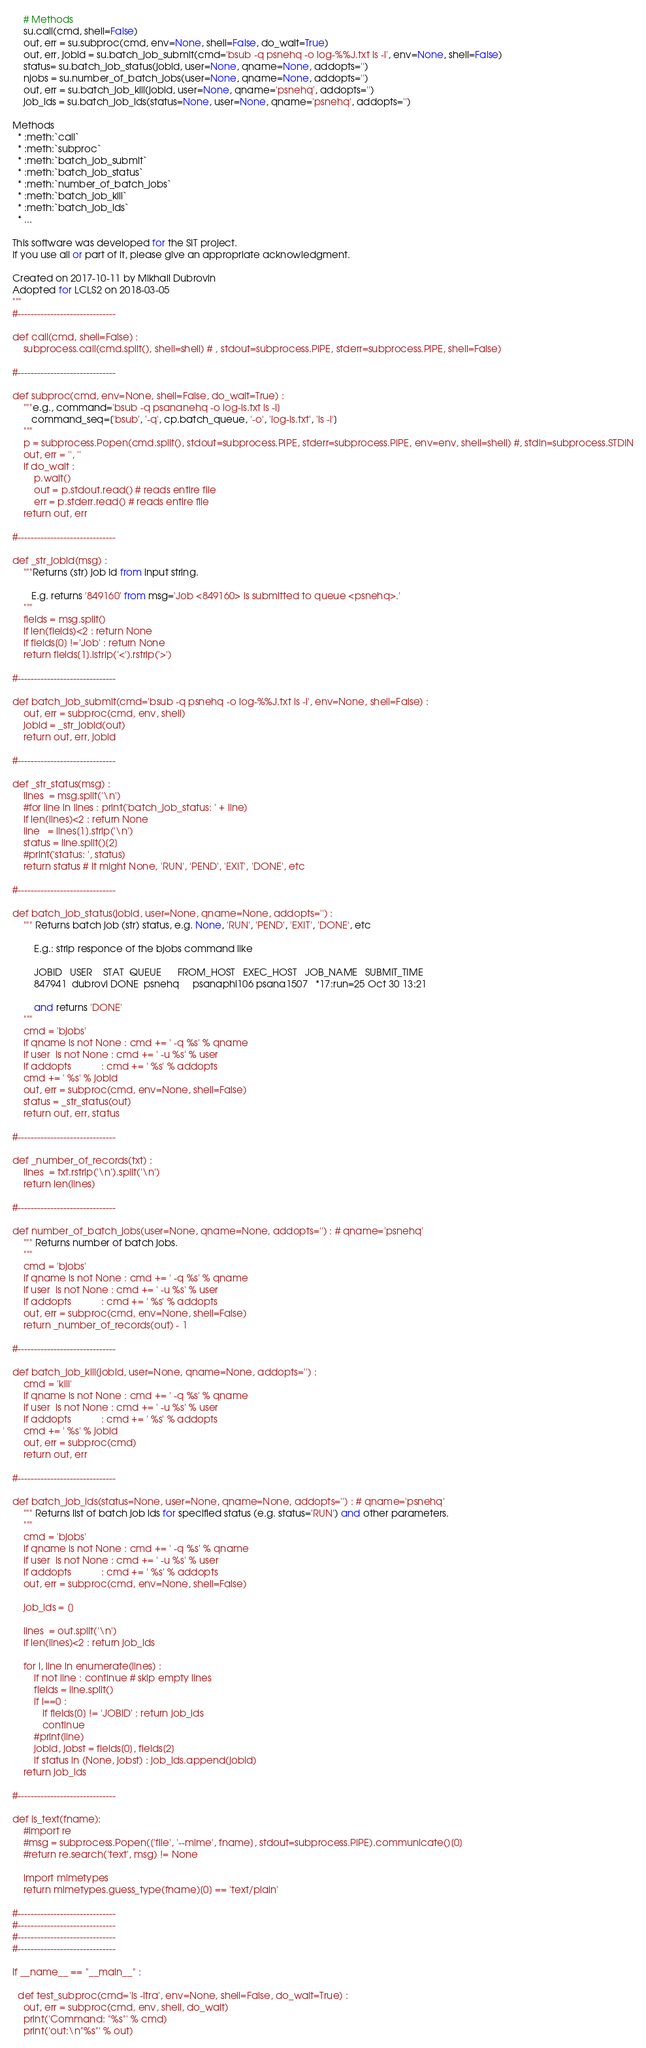Convert code to text. <code><loc_0><loc_0><loc_500><loc_500><_Python_>    # Methods
    su.call(cmd, shell=False)
    out, err = su.subproc(cmd, env=None, shell=False, do_wait=True)
    out, err, jobid = su.batch_job_submit(cmd='bsub -q psnehq -o log-%%J.txt ls -l', env=None, shell=False)
    status= su.batch_job_status(jobid, user=None, qname=None, addopts='')
    njobs = su.number_of_batch_jobs(user=None, qname=None, addopts='')
    out, err = su.batch_job_kill(jobid, user=None, qname='psnehq', addopts='')
    job_ids = su.batch_job_ids(status=None, user=None, qname='psnehq', addopts='')

Methods 
  * :meth:`call`
  * :meth:`subproc`
  * :meth:`batch_job_submit`
  * :meth:`batch_job_status`
  * :meth:`number_of_batch_jobs`
  * :meth:`batch_job_kill`
  * :meth:`batch_job_ids`
  * ...

This software was developed for the SIT project.
If you use all or part of it, please give an appropriate acknowledgment.

Created on 2017-10-11 by Mikhail Dubrovin
Adopted for LCLS2 on 2018-03-05
"""
#------------------------------

def call(cmd, shell=False) :
    subprocess.call(cmd.split(), shell=shell) # , stdout=subprocess.PIPE, stderr=subprocess.PIPE, shell=False)

#------------------------------

def subproc(cmd, env=None, shell=False, do_wait=True) :
    """e.g., command='bsub -q psananehq -o log-ls.txt ls -l]
       command_seq=['bsub', '-q', cp.batch_queue, '-o', 'log-ls.txt', 'ls -l']
    """
    p = subprocess.Popen(cmd.split(), stdout=subprocess.PIPE, stderr=subprocess.PIPE, env=env, shell=shell) #, stdin=subprocess.STDIN
    out, err = '', ''
    if do_wait : 
        p.wait()
        out = p.stdout.read() # reads entire file
        err = p.stderr.read() # reads entire file
    return out, err

#------------------------------

def _str_jobid(msg) :
    """Returns (str) job Id from input string.

       E.g. returns '849160' from msg='Job <849160> is submitted to queue <psnehq>.'
    """
    fields = msg.split()
    if len(fields)<2 : return None
    if fields[0] !='Job' : return None
    return fields[1].lstrip('<').rstrip('>')

#------------------------------

def batch_job_submit(cmd='bsub -q psnehq -o log-%%J.txt ls -l', env=None, shell=False) :
    out, err = subproc(cmd, env, shell)
    jobid = _str_jobid(out)
    return out, err, jobid

#------------------------------

def _str_status(msg) :
    lines  = msg.split('\n')
    #for line in lines : print('batch_job_status: ' + line)
    if len(lines)<2 : return None
    line   = lines[1].strip('\n')
    status = line.split()[2]
    #print('status: ', status)
    return status # it might None, 'RUN', 'PEND', 'EXIT', 'DONE', etc 

#------------------------------

def batch_job_status(jobid, user=None, qname=None, addopts='') :
    """ Returns batch job (str) status, e.g. None, 'RUN', 'PEND', 'EXIT', 'DONE', etc 

        E.g.: strip responce of the bjobs command like

        JOBID   USER    STAT  QUEUE      FROM_HOST   EXEC_HOST   JOB_NAME   SUBMIT_TIME
        847941  dubrovi DONE  psnehq     psanaphi106 psana1507   *17:run=25 Oct 30 13:21

        and returns 'DONE'
    """
    cmd = 'bjobs'
    if qname is not None : cmd += ' -q %s' % qname
    if user  is not None : cmd += ' -u %s' % user
    if addopts           : cmd += ' %s' % addopts
    cmd += ' %s' % jobid
    out, err = subproc(cmd, env=None, shell=False)
    status = _str_status(out)
    return out, err, status

#------------------------------

def _number_of_records(txt) :
    lines  = txt.rstrip('\n').split('\n')
    return len(lines)

#------------------------------

def number_of_batch_jobs(user=None, qname=None, addopts='') : # qname='psnehq'
    """ Returns number of batch jobs.
    """
    cmd = 'bjobs'
    if qname is not None : cmd += ' -q %s' % qname
    if user  is not None : cmd += ' -u %s' % user
    if addopts           : cmd += ' %s' % addopts
    out, err = subproc(cmd, env=None, shell=False)
    return _number_of_records(out) - 1

#------------------------------

def batch_job_kill(jobid, user=None, qname=None, addopts='') :
    cmd = 'kill'
    if qname is not None : cmd += ' -q %s' % qname
    if user  is not None : cmd += ' -u %s' % user
    if addopts           : cmd += ' %s' % addopts
    cmd += ' %s' % jobid
    out, err = subproc(cmd)
    return out, err

#------------------------------

def batch_job_ids(status=None, user=None, qname=None, addopts='') : # qname='psnehq'
    """ Returns list of batch job ids for specified status (e.g. status='RUN') and other parameters.
    """
    cmd = 'bjobs'
    if qname is not None : cmd += ' -q %s' % qname
    if user  is not None : cmd += ' -u %s' % user
    if addopts           : cmd += ' %s' % addopts
    out, err = subproc(cmd, env=None, shell=False)

    job_ids = []

    lines  = out.split('\n')
    if len(lines)<2 : return job_ids

    for i, line in enumerate(lines) :
        if not line : continue # skip empty lines
        fields = line.split()
        if i==0 :
           if fields[0] != 'JOBID' : return job_ids
           continue
        #print(line)
        jobid, jobst = fields[0], fields[2]
        if status in (None, jobst) : job_ids.append(jobid)
    return job_ids

#------------------------------

def is_text(fname):
    #import re
    #msg = subprocess.Popen(['file', '--mime', fname], stdout=subprocess.PIPE).communicate()[0]
    #return re.search('text', msg) != None

    import mimetypes
    return mimetypes.guess_type(fname)[0] == 'text/plain'

#------------------------------
#------------------------------
#------------------------------
#------------------------------

if __name__ == "__main__" :

  def test_subproc(cmd='ls -ltra', env=None, shell=False, do_wait=True) :
    out, err = subproc(cmd, env, shell, do_wait)
    print('Command: "%s"' % cmd)
    print('out:\n"%s"' % out)</code> 